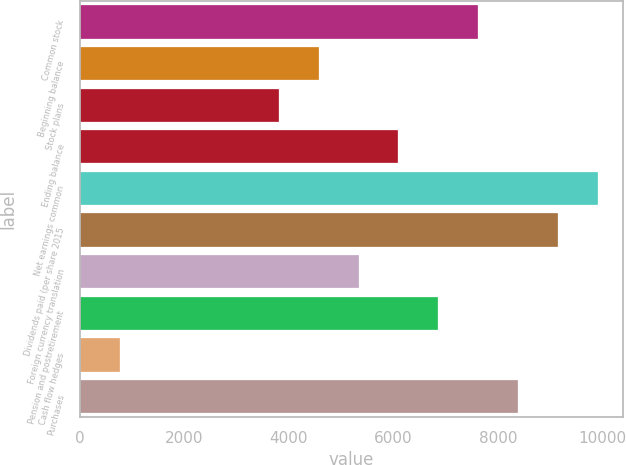Convert chart to OTSL. <chart><loc_0><loc_0><loc_500><loc_500><bar_chart><fcel>Common stock<fcel>Beginning balance<fcel>Stock plans<fcel>Ending balance<fcel>Net earnings common<fcel>Dividends paid (per share 2015<fcel>Foreign currency translation<fcel>Pension and postretirement<fcel>Cash flow hedges<fcel>Purchases<nl><fcel>7618<fcel>4571.6<fcel>3810<fcel>6094.8<fcel>9902.8<fcel>9141.2<fcel>5333.2<fcel>6856.4<fcel>763.6<fcel>8379.6<nl></chart> 